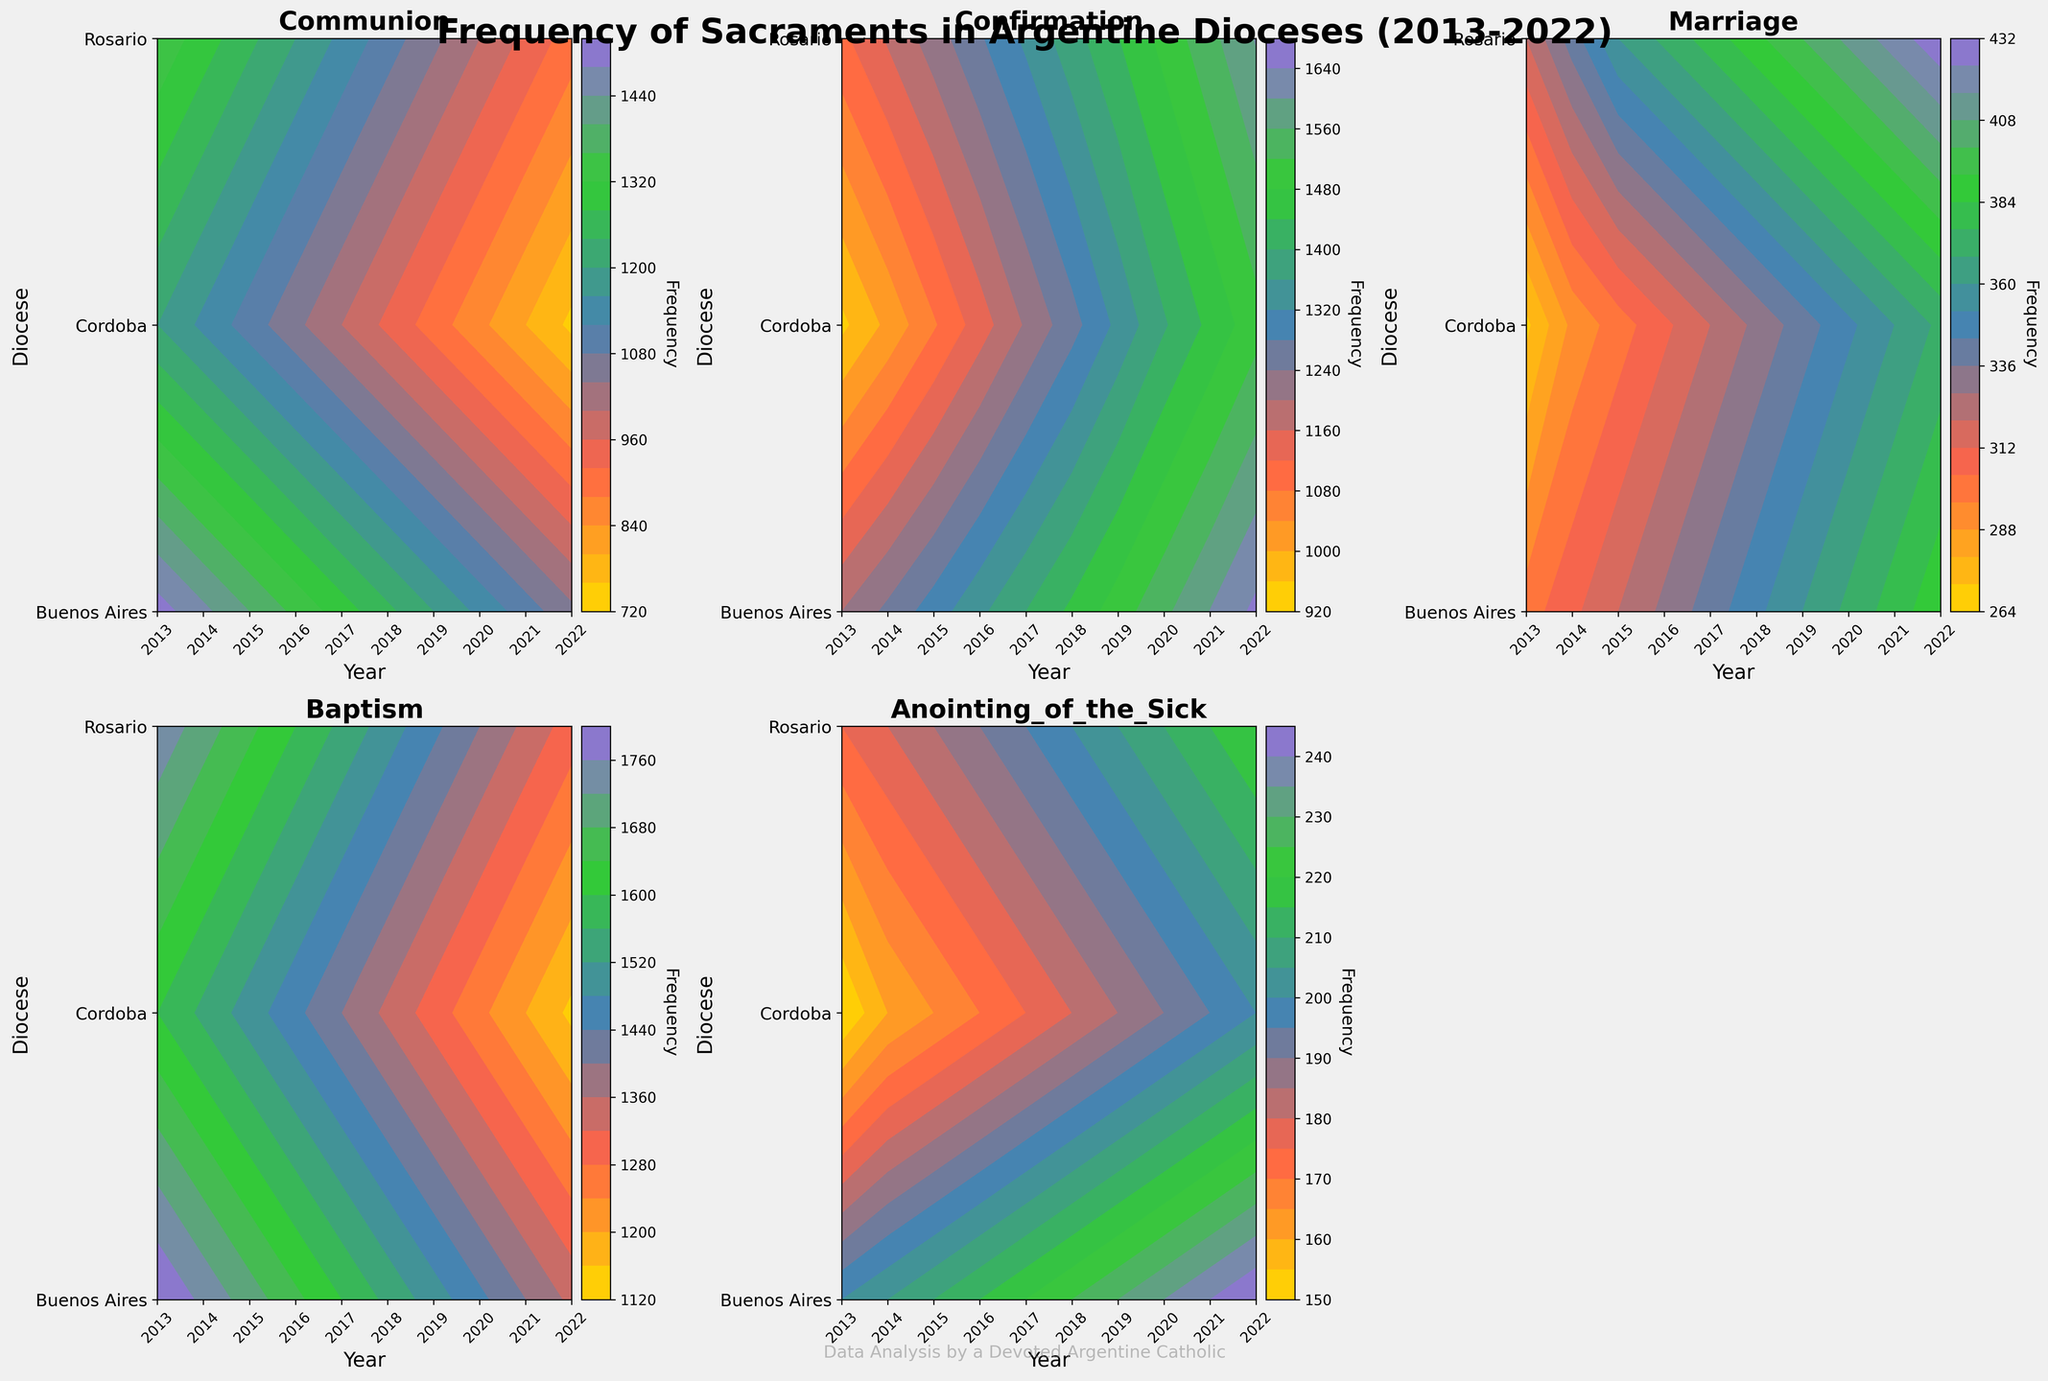What is the title of the figure? The title is typically positioned at the top of the figure and is in large, bold font to draw attention. It's written as: "Frequency of Sacraments in Argentine Dioceses (2013-2022)".
Answer: Frequency of Sacraments in Argentine Dioceses (2013-2022) Which sacraments are displayed in the figure? The sacraments are listed in each subplot title of the figure, located at the top of each smaller graph within the main figure. They include: Communion, Confirmation, Marriage, Baptism, and Anointing of the Sick.
Answer: Communion, Confirmation, Marriage, Baptism, Anointing of the Sick How does the frequency of Baptism in Buenos Aires change from 2013 to 2022? To determine this, you can inspect the contour plot line representing Buenos Aires on the Baptism subplot. Identify the contour values at the beginning and end of the decade. Starting from 1800 in 2013 and ending at 1350 in 2022, the frequency has decreased over time.
Answer: Decreased from 1800 to 1350 Which diocese had the highest frequency of Confirmation in 2022? By examining the contour lines on the Confirmation subplot for the year 2022, we find that the diocese with the highest frequency is Rosario with a value reflecting 1603.
Answer: Rosario What trend is observed in the frequency of Marriage in Cordoba from 2013 to 2022? Look at the contour plot for Marriage and trace the lines for Cordoba from 2013 to 2022. Cordoba's frequency starts at 270 in 2013 and increases gradually to 370 by 2022, showing an overall increasing trend.
Answer: Overall increasing trend Compare the change in the frequency of Anointing of the Sick between Buenos Aires and Cordoba from 2013 to 2022. For Buenos Aires, examine the Anointing of the Sick subplot and note the increase from 200 in 2013 to 245 in 2022. For Cordoba, the frequency increases from 150 in 2013 to 200 in 2022. Both dioceses show an increasing trend, but Buenos Aires has a slightly higher total increase.
Answer: Both increases, Buenos Aires has a higher total increase Which sacrament shows the least variation over the decade in Buenos Aires? To assess variation, compare the contour density for each sacrament in Buenos Aires. Marriage has the smallest change, fluctuating only around 300 to 390. This indicates relatively small variation compared to other sacraments.
Answer: Marriage Identify one sacrament where the frequency peaks for all dioceses around the same period. By looking at the contour peaks for each sacrament, Confirmation peaks around 2022 across Buenos Aires, Cordoba, and Rosario.
Answer: Confirmation Calculate the average frequency of Communion in Rosario over the decade. Sum the frequencies of Communion for Rosario from 2013 to 2022: 1350 + 1300 + 1250 + 1200 + 1150 + 1100 + 1050 + 1000 + 950 = 11350. Divide this sum by the 10 years: 11350 / 10 = 1135.
Answer: 1135 